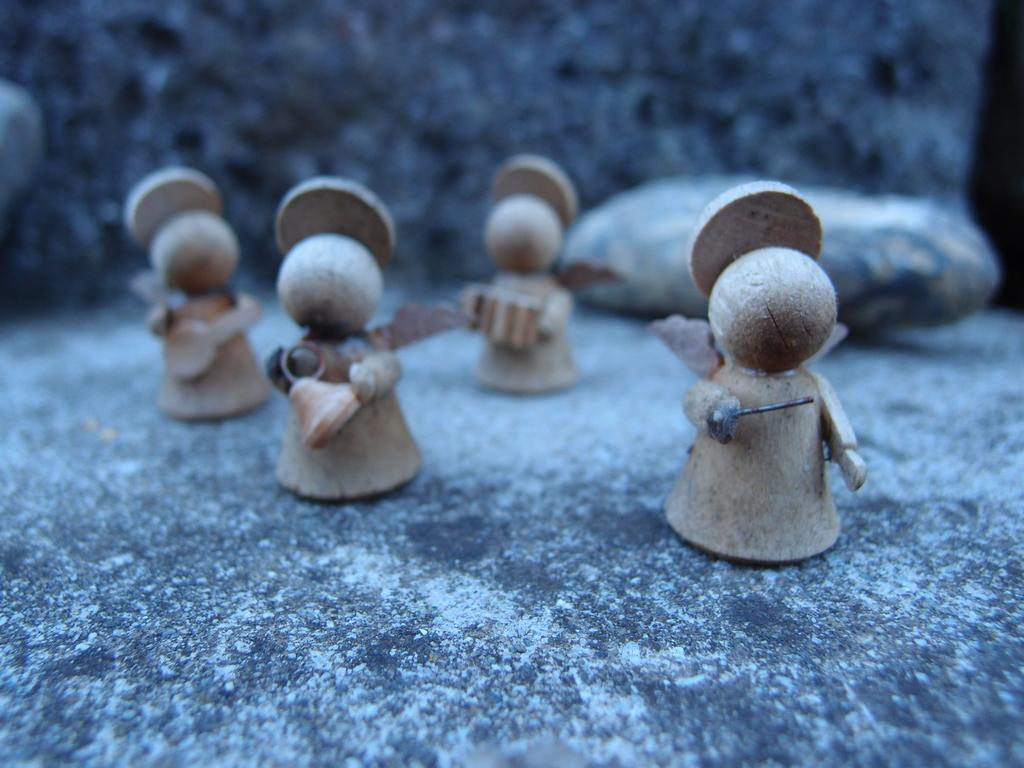What is placed on the floor in the image? There are toys placed on the floor. Can you describe the toys in the image? The image only shows toys placed on the floor, but no specific details about the toys are provided. Are there any other objects or figures in the image? The image only shows toys placed on the floor, so there are no other objects or figures visible. What street is the cause of the thrill in the image? There is no street, cause, or thrill present in the image, as it only features toys placed on the floor. 